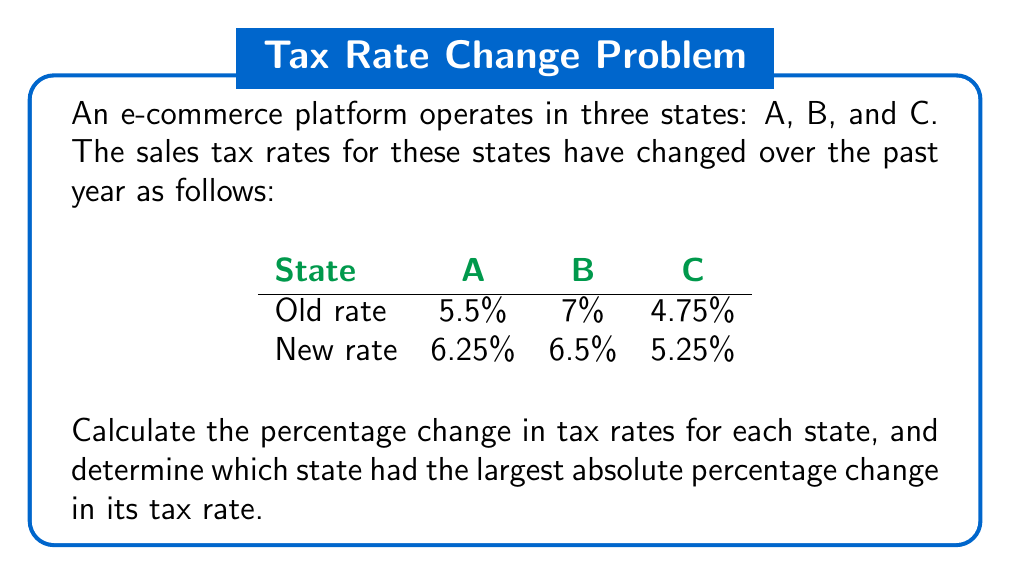Help me with this question. To calculate the percentage change in tax rates, we'll use the formula:

$$ \text{Percentage Change} = \frac{\text{New Value} - \text{Original Value}}{\text{Original Value}} \times 100\% $$

For State A:
$$ \text{Percentage Change}_A = \frac{6.25\% - 5.5\%}{5.5\%} \times 100\% = \frac{0.75\%}{5.5\%} \times 100\% \approx 13.64\% $$

For State B:
$$ \text{Percentage Change}_B = \frac{6.5\% - 7\%}{7\%} \times 100\% = \frac{-0.5\%}{7\%} \times 100\% \approx -7.14\% $$

For State C:
$$ \text{Percentage Change}_C = \frac{5.25\% - 4.75\%}{4.75\%} \times 100\% = \frac{0.5\%}{4.75\%} \times 100\% \approx 10.53\% $$

To determine which state had the largest absolute percentage change, we compare the absolute values of the percentage changes:

State A: $|13.64\%|$ = 13.64%
State B: $|-7.14\%|$ = 7.14%
State C: $|10.53\%|$ = 10.53%

The largest absolute percentage change is 13.64% for State A.
Answer: State A: 13.64% increase; State B: 7.14% decrease; State C: 10.53% increase. Largest absolute change: State A (13.64%). 